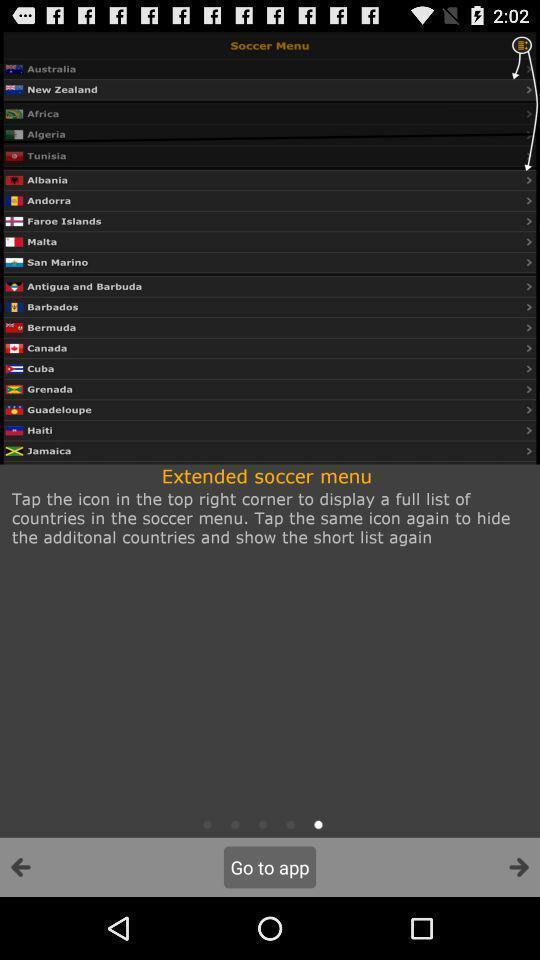Provide a detailed account of this screenshot. Page showing multiple countries with some content. 